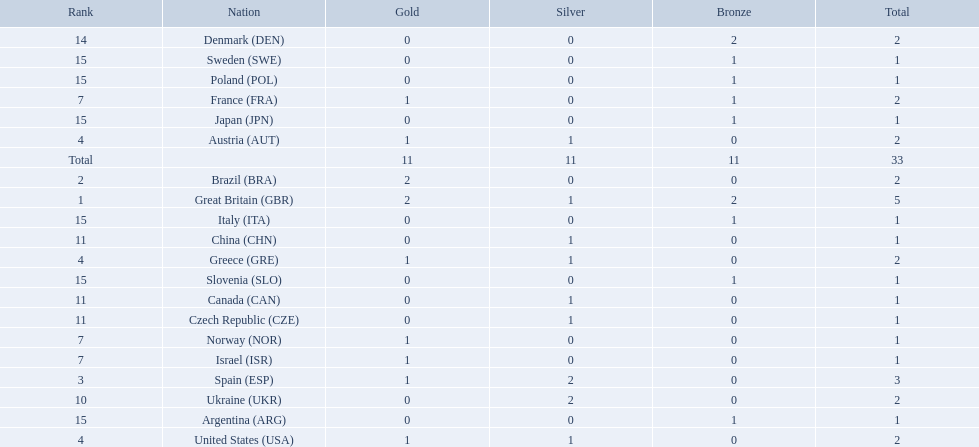What are all of the countries? Great Britain (GBR), Brazil (BRA), Spain (ESP), Austria (AUT), Greece (GRE), United States (USA), France (FRA), Israel (ISR), Norway (NOR), Ukraine (UKR), China (CHN), Czech Republic (CZE), Canada (CAN), Denmark (DEN), Argentina (ARG), Italy (ITA), Japan (JPN), Poland (POL), Slovenia (SLO), Sweden (SWE). Which ones earned a medal? Great Britain (GBR), Brazil (BRA), Spain (ESP), Austria (AUT), Greece (GRE), United States (USA), France (FRA), Israel (ISR), Norway (NOR), Ukraine (UKR), China (CHN), Czech Republic (CZE), Canada (CAN), Denmark (DEN), Argentina (ARG), Italy (ITA), Japan (JPN), Poland (POL), Slovenia (SLO), Sweden (SWE). Which countries earned at least 3 medals? Great Britain (GBR), Spain (ESP). Which country earned 3 medals? Spain (ESP). 